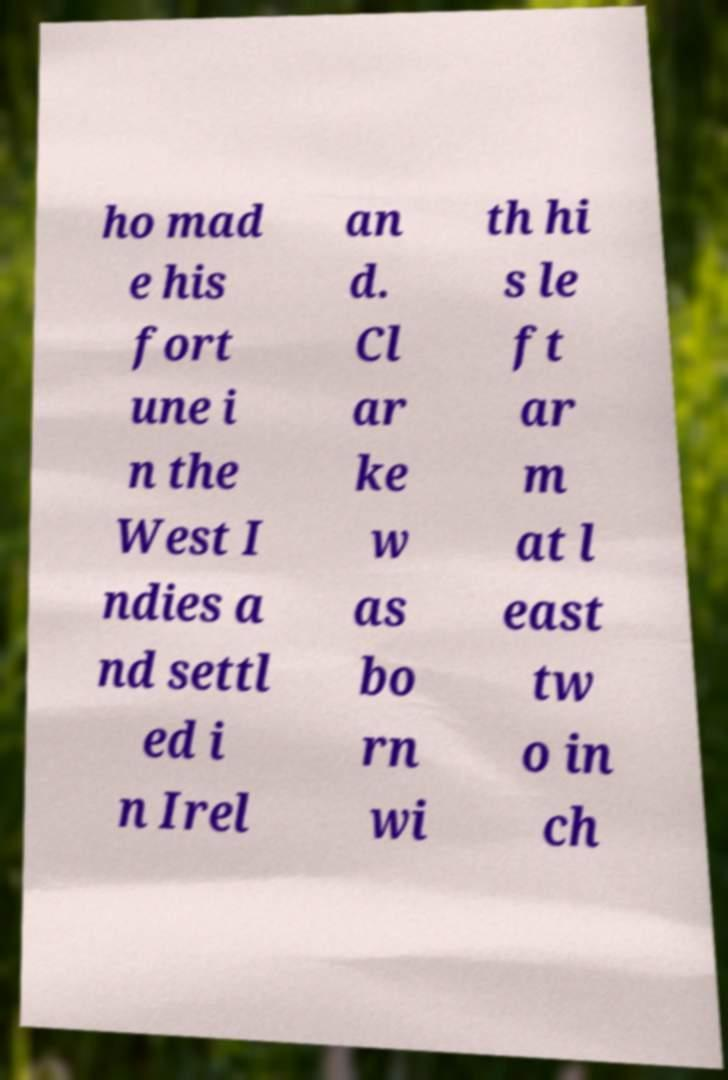Please read and relay the text visible in this image. What does it say? ho mad e his fort une i n the West I ndies a nd settl ed i n Irel an d. Cl ar ke w as bo rn wi th hi s le ft ar m at l east tw o in ch 